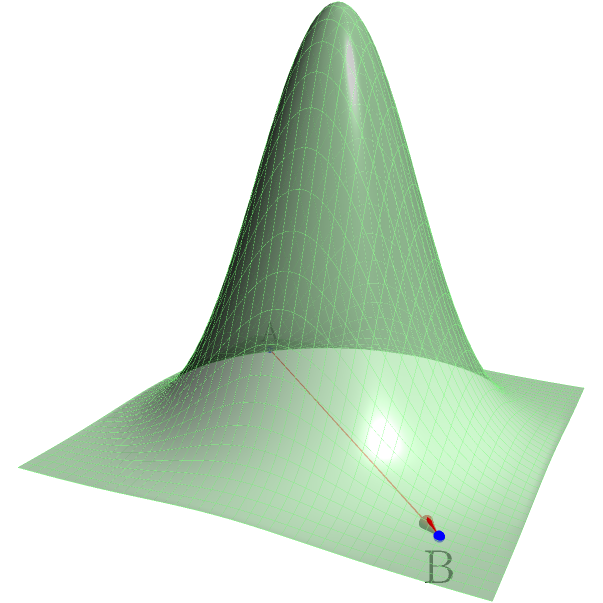As an alpinist searching for rare botanical specimens, you encounter a challenging terrain depicted in the 3D model above. You need to travel from point A to point B. The surface represents the elevation of the terrain, with higher elevations corresponding to greater z-values. What is the most efficient path to take, and how does it differ from a straight line between the two points? To determine the most efficient path between points A and B on this 3D terrain, we need to consider the following steps:

1. Analyze the terrain: The surface is a Gaussian function, with the highest point at the center and decreasing elevation as we move away from the center.

2. Straight line vs. curved path:
   a) A straight line (shown in red) would cross over the highest part of the terrain, requiring more energy to climb and descend.
   b) The most efficient path would curve around the peak, avoiding unnecessary elevation gain and loss.

3. Geodesic principle: The shortest path between two points on a curved surface is called a geodesic. In this case, the geodesic would follow a curve that balances the trade-off between distance traveled and elevation change.

4. Path characteristics:
   a) The path would start by curving away from the center of the surface.
   b) It would then gradually approach the straight line as it gets closer to point B.

5. Energy consideration: The most efficient path minimizes the total work done, which is a combination of horizontal distance traveled and vertical elevation change.

6. Mathematical formulation: Finding the exact path would require solving the geodesic equation for this surface, which is a complex differential equation.

7. Practical approach: In real-world scenarios, alpinists often use a combination of topographic map reading, visual assessment, and experience to approximate the most efficient route.
Answer: A curved path around the peak, approximating a geodesic. 